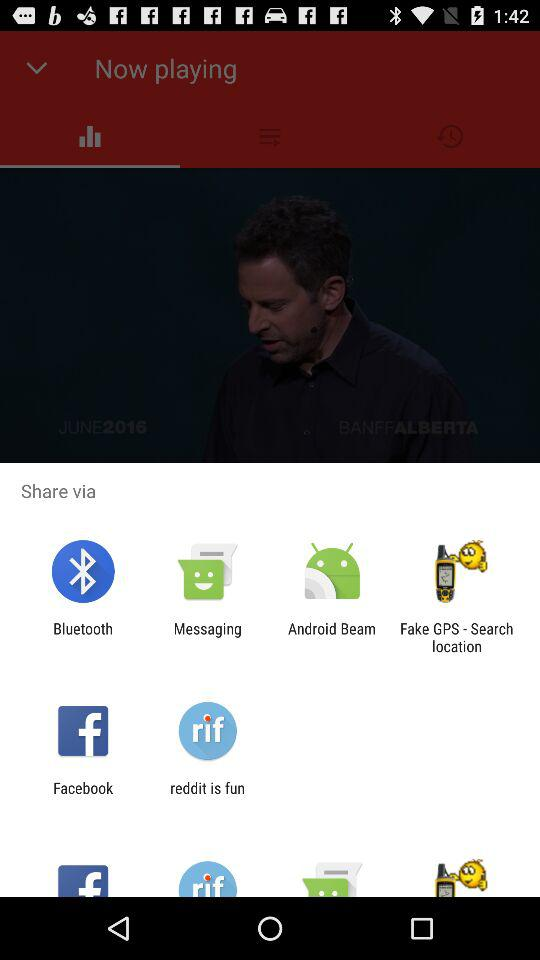Through what application can it be shared? It can be shared through "Bluetooth", "Messaging", "Android Beam", "Fake GPS - Search location", "Facebook", and "reddit is fun". 